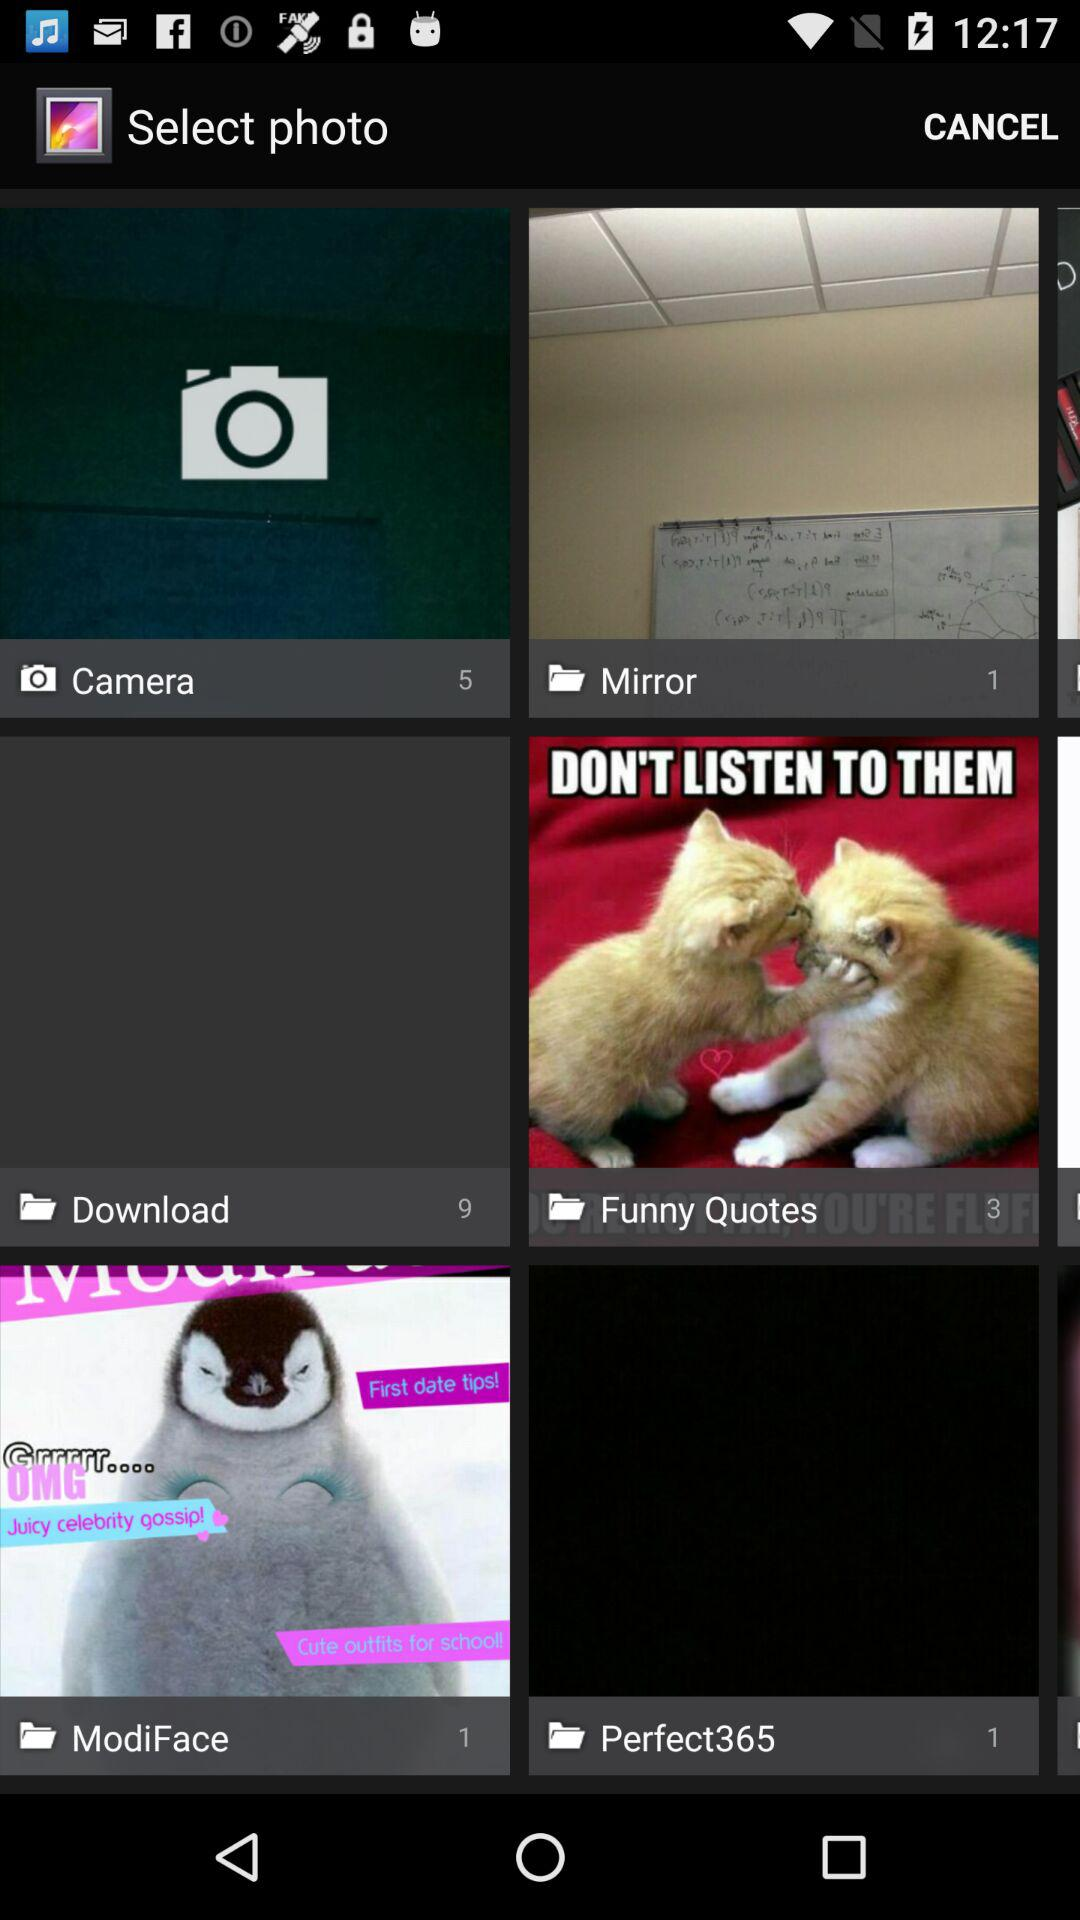What is the number of images in the "ModiFace"? "ModiFace" contains one image. 